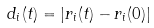<formula> <loc_0><loc_0><loc_500><loc_500>d _ { i } ( t ) = \left | r _ { i } ( t ) - r _ { i } ( 0 ) \right |</formula> 